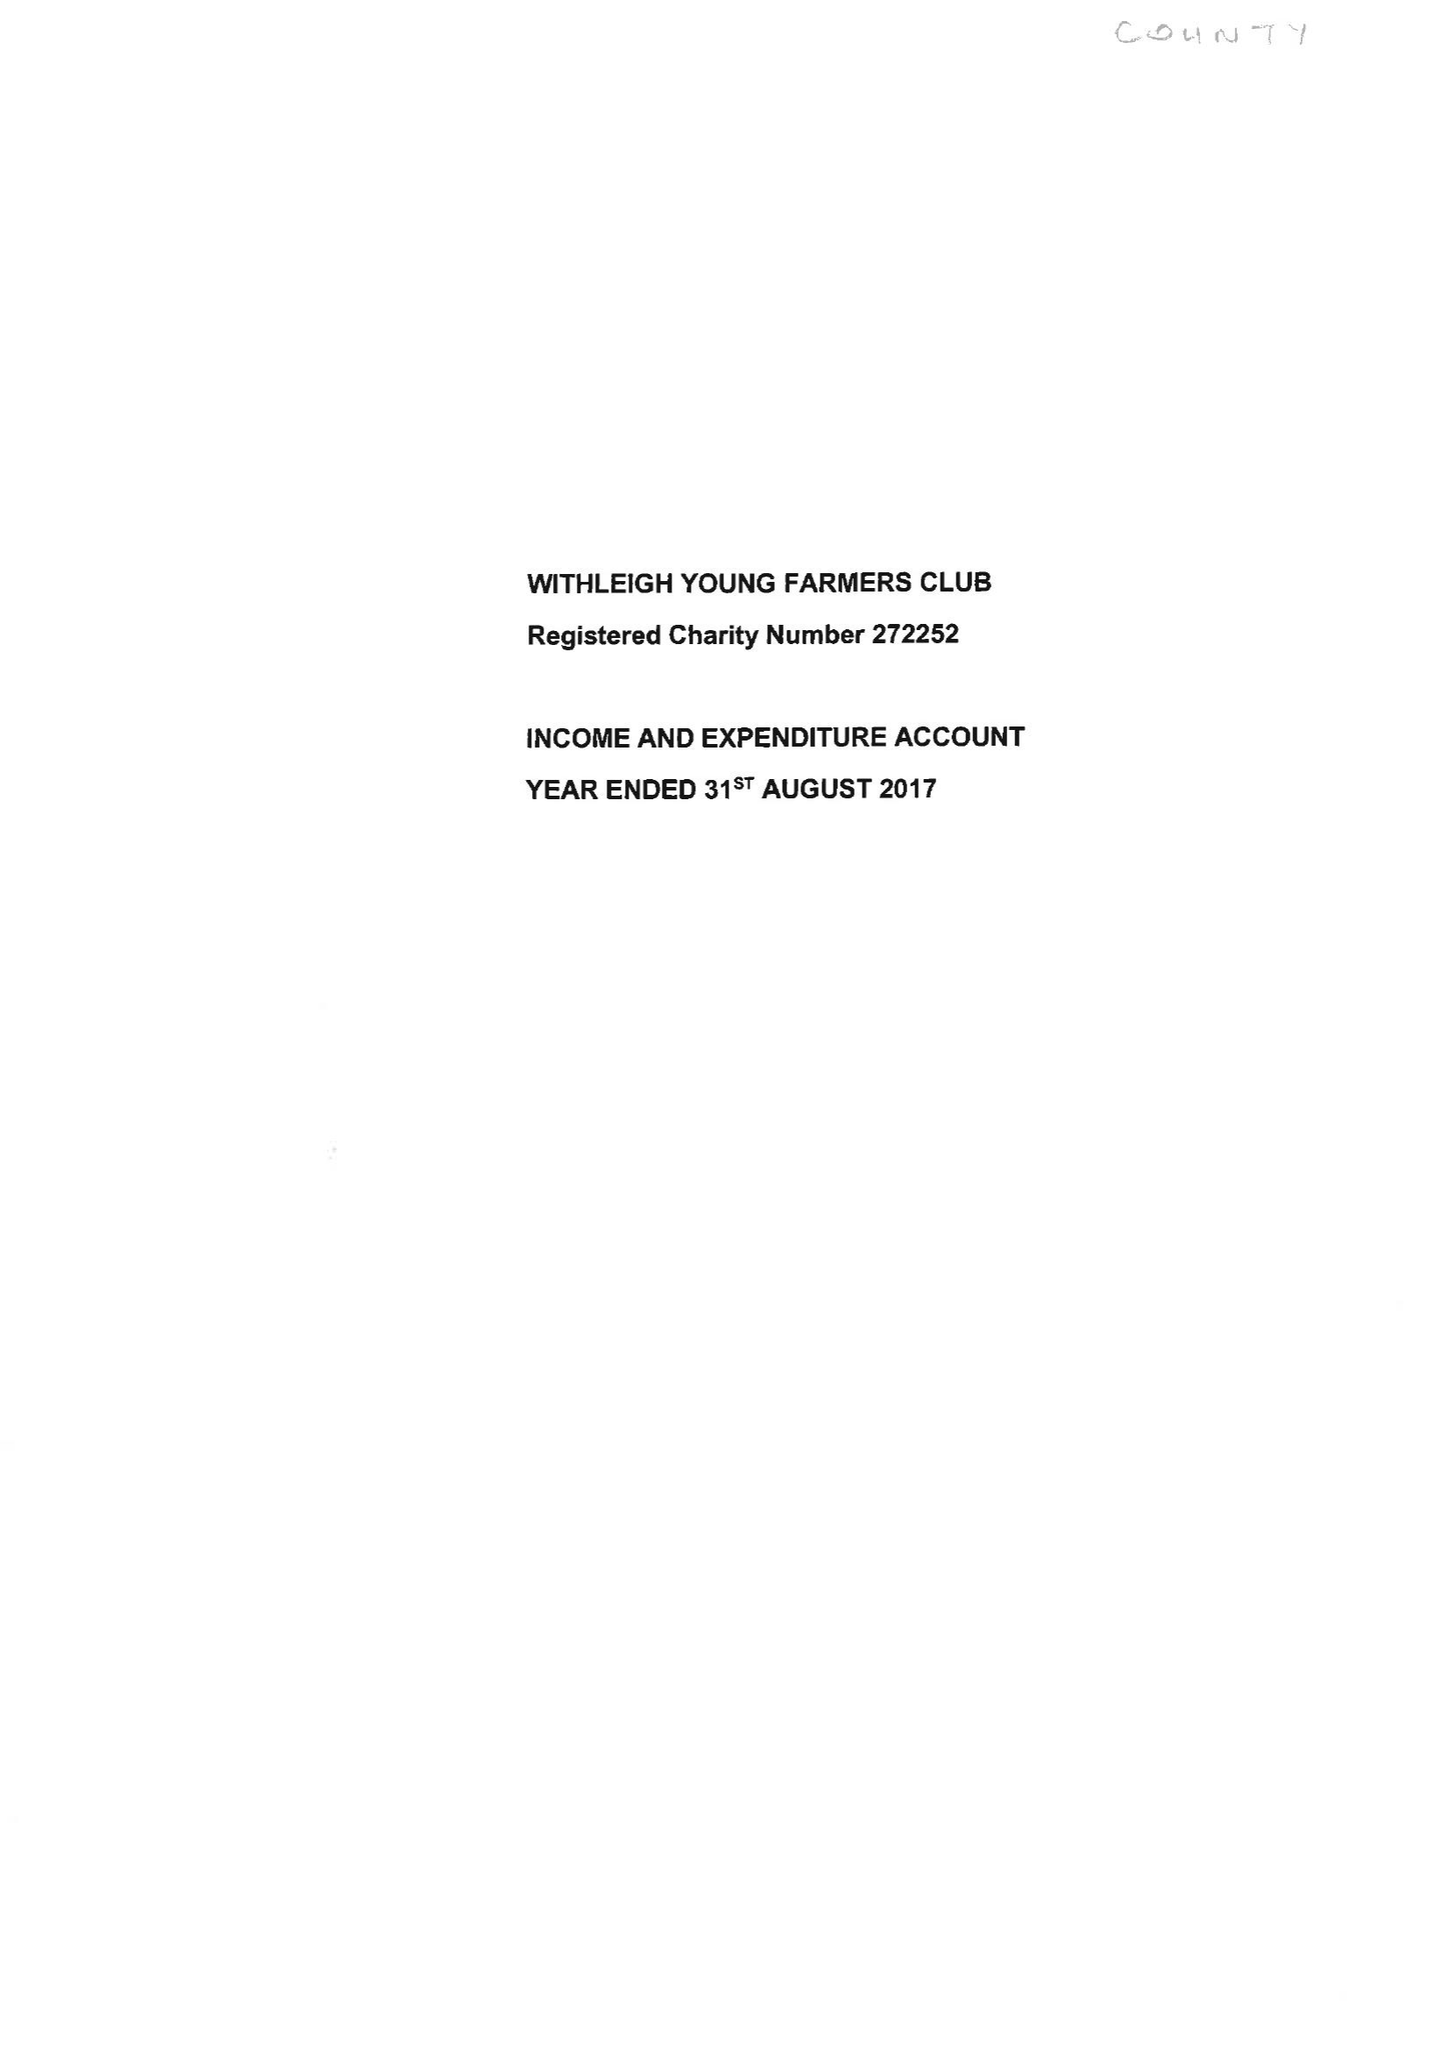What is the value for the charity_name?
Answer the question using a single word or phrase. Withleigh Young Farmers Club 